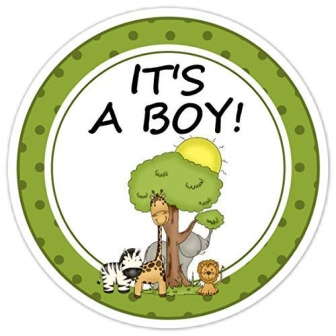Can you tell me about the scene depicted in this sticker? This sticker illustrates an inviting outdoor scene in a cartoon style. At its center, three animals - a giraffe, a zebra, and a lion - are happily gathered under a tree, suggesting the wild African savanna. A yellow bird perches cheerfully on a branch, adding life and whimsy to the illustration. The background hosts a bright yellow sun, further illuminating the playful atmosphere. The text 'IT'S A BOY!' is prominently displayed, celebrating the birth of a baby boy. 